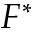Convert formula to latex. <formula><loc_0><loc_0><loc_500><loc_500>F ^ { \ast }</formula> 